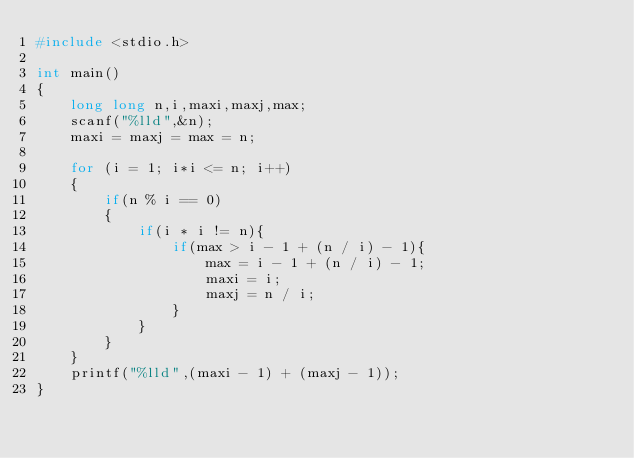<code> <loc_0><loc_0><loc_500><loc_500><_C_>#include <stdio.h>

int main()
{
    long long n,i,maxi,maxj,max;
    scanf("%lld",&n);
    maxi = maxj = max = n;

    for (i = 1; i*i <= n; i++)
    {
        if(n % i == 0)
        {
            if(i * i != n){
                if(max > i - 1 + (n / i) - 1){
                    max = i - 1 + (n / i) - 1;
                    maxi = i;
                    maxj = n / i;
                }
            }
        }
    }
    printf("%lld",(maxi - 1) + (maxj - 1));
}
</code> 